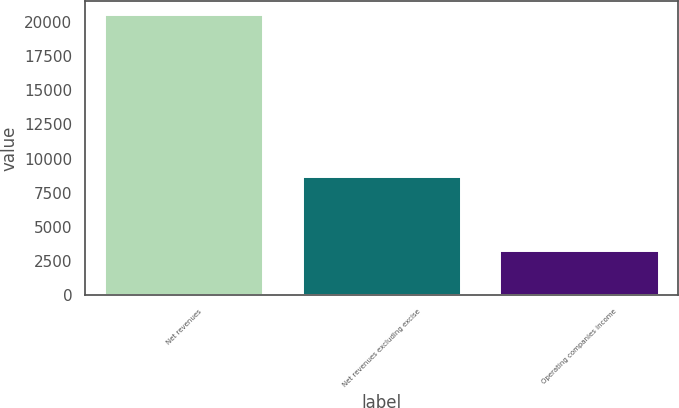Convert chart. <chart><loc_0><loc_0><loc_500><loc_500><bar_chart><fcel>Net revenues<fcel>Net revenues excluding excise<fcel>Operating companies income<nl><fcel>20531<fcel>8681<fcel>3196<nl></chart> 